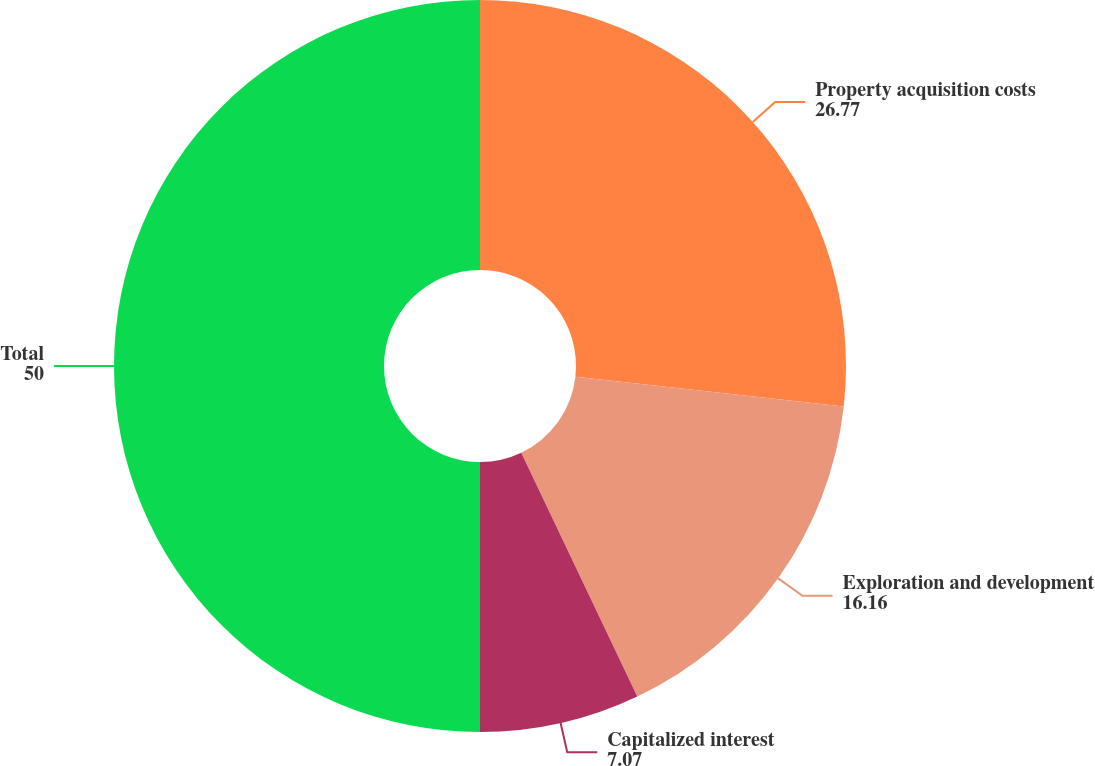<chart> <loc_0><loc_0><loc_500><loc_500><pie_chart><fcel>Property acquisition costs<fcel>Exploration and development<fcel>Capitalized interest<fcel>Total<nl><fcel>26.77%<fcel>16.16%<fcel>7.07%<fcel>50.0%<nl></chart> 